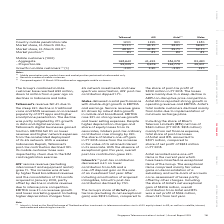According to Singapore Telecommunications's financial document, Which market does the information reflect for Airtel? According to the financial document, India. The relevant text states: "lion from a year ago on declines in Indonesia and India. Telkomsel’s revenue fell 4% due to the steep 24% decline in traditional voice and SMS revenues on..." Also, What is the market position of AIS? According to the financial document, #1. The relevant text states: "18 (2) 48.5% 44.8% 25.7% 52.1% Market position (2) #1 #1 #2 #1..." Also, What is the % growth of mobile customers for AIS? According to the financial document, 3.6%. The relevant text states: "770 39,307 Growth in mobile customers (3) (%) -13% 3.6% -2.9% 32%..." Additionally, Which associate had the best % growth in mobile customers? According to the financial document, Globe. The relevant text states: "Telkomsel AIS Airtel (1) Globe..." Additionally, Which associate has the worst market position? According to the financial document, Airtel. The relevant text states: "Telkomsel AIS Airtel (1) Globe..." Additionally, Which associate had the biggest change in market share from 2018 to 2019? According to the financial document, Globe. The relevant text states: "Telkomsel AIS Airtel (1) Globe..." 